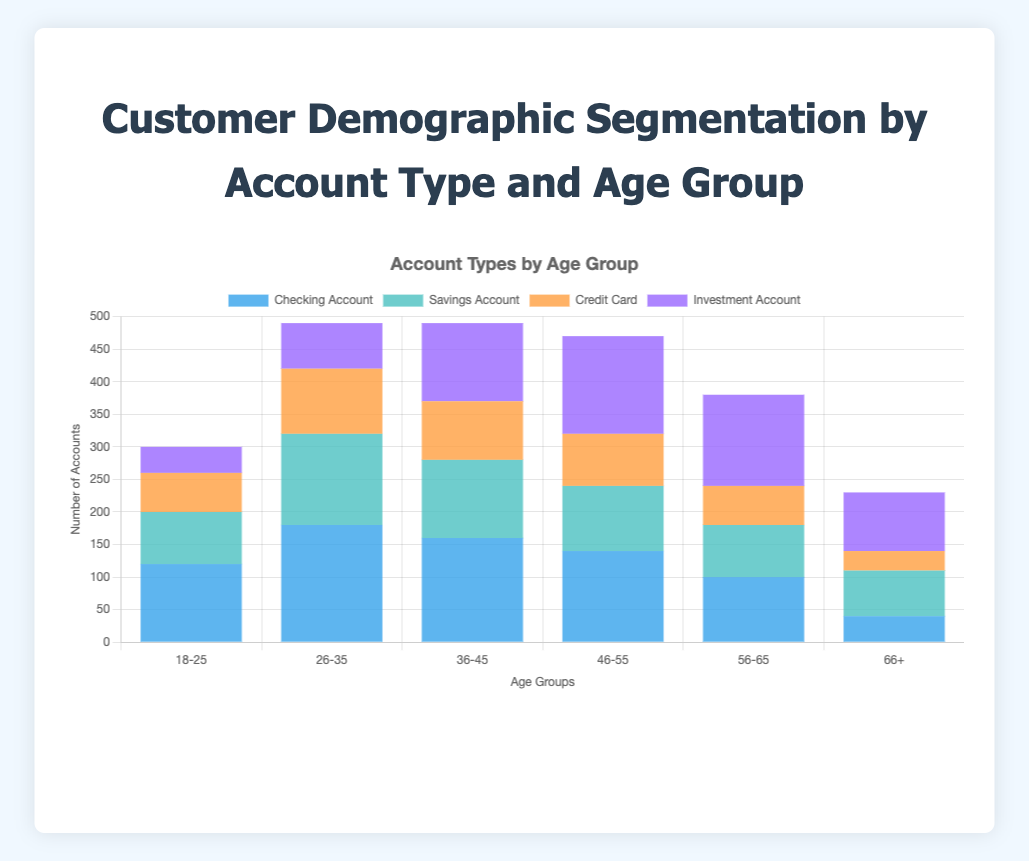What age group has the highest number of checking accounts? By observing the height of the bars representing the checking accounts, we can see that the 26-35 age group has the tallest bar for checking accounts.
Answer: 26-35 What is the total number of investment accounts held by customers aged 46-55 and 56-65? We add the number of investment accounts for ages 46-55 (150) and 56-65 (140). Summing them up gives us 150 + 140 = 290.
Answer: 290 Between which two age groups is the difference in the number of savings accounts the greatest? By comparing the heights of the savings account bars, the biggest difference is between the 26-35 group (140 accounts) and the 18-25 group (80 accounts). The difference is 140 - 80 = 60.
Answer: 26-35 and 18-25 Which account type is the most popular among customers aged 36-45? The tallest bar within the 36-45 age group is for checking accounts, indicating they have the highest count.
Answer: Checking Account Is the total number of credit cards owned by customers over 55 years old greater than that of customers under 55 years old? Summing credit cards for ages 56-65 (60) and 66+ (30) gives 60 + 30 = 90. Summing for ages 18-25 (60), 26-35 (100), 36-45 (90), and 46-55 (80) gives 60 + 100 + 90 + 80 = 330. Comparing 90 to 330, 90 is less than 330.
Answer: No What is the combined total of all account types for the 18-25 age group? Adding the number of all accounts in the 18-25 age group: 120 (checking) + 80 (savings) + 60 (credit card) + 40 (investment) results in 120 + 80 + 60 + 40 = 300.
Answer: 300 Which age group has more investment accounts than checking accounts? By comparing the bars for investment and checking accounts, only the 66+ group has more investment accounts (90) compared to checking accounts (40).
Answer: 66+ What is the average number of savings accounts across all age groups? Sum the number of savings accounts: 80 + 140 + 120 + 100 + 80 + 70 = 590, then 590 divided by 6 age groups equals approximately 98.33.
Answer: 98.33 How many more customers have checking accounts than credit cards overall? Sum the checking accounts: 120 + 180 + 160 + 140 + 100 + 40 = 740, sum the credit cards: 60 + 100 + 90 + 80 + 60 + 30 = 420, and find the difference: 740 - 420 = 320.
Answer: 320 